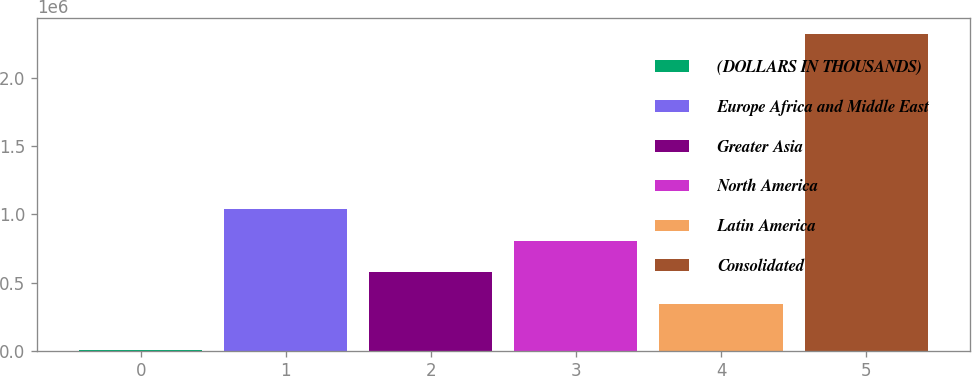<chart> <loc_0><loc_0><loc_500><loc_500><bar_chart><fcel>(DOLLARS IN THOUSANDS)<fcel>Europe Africa and Middle East<fcel>Greater Asia<fcel>North America<fcel>Latin America<fcel>Consolidated<nl><fcel>2009<fcel>1.04081e+06<fcel>575983<fcel>808398<fcel>343568<fcel>2.32616e+06<nl></chart> 